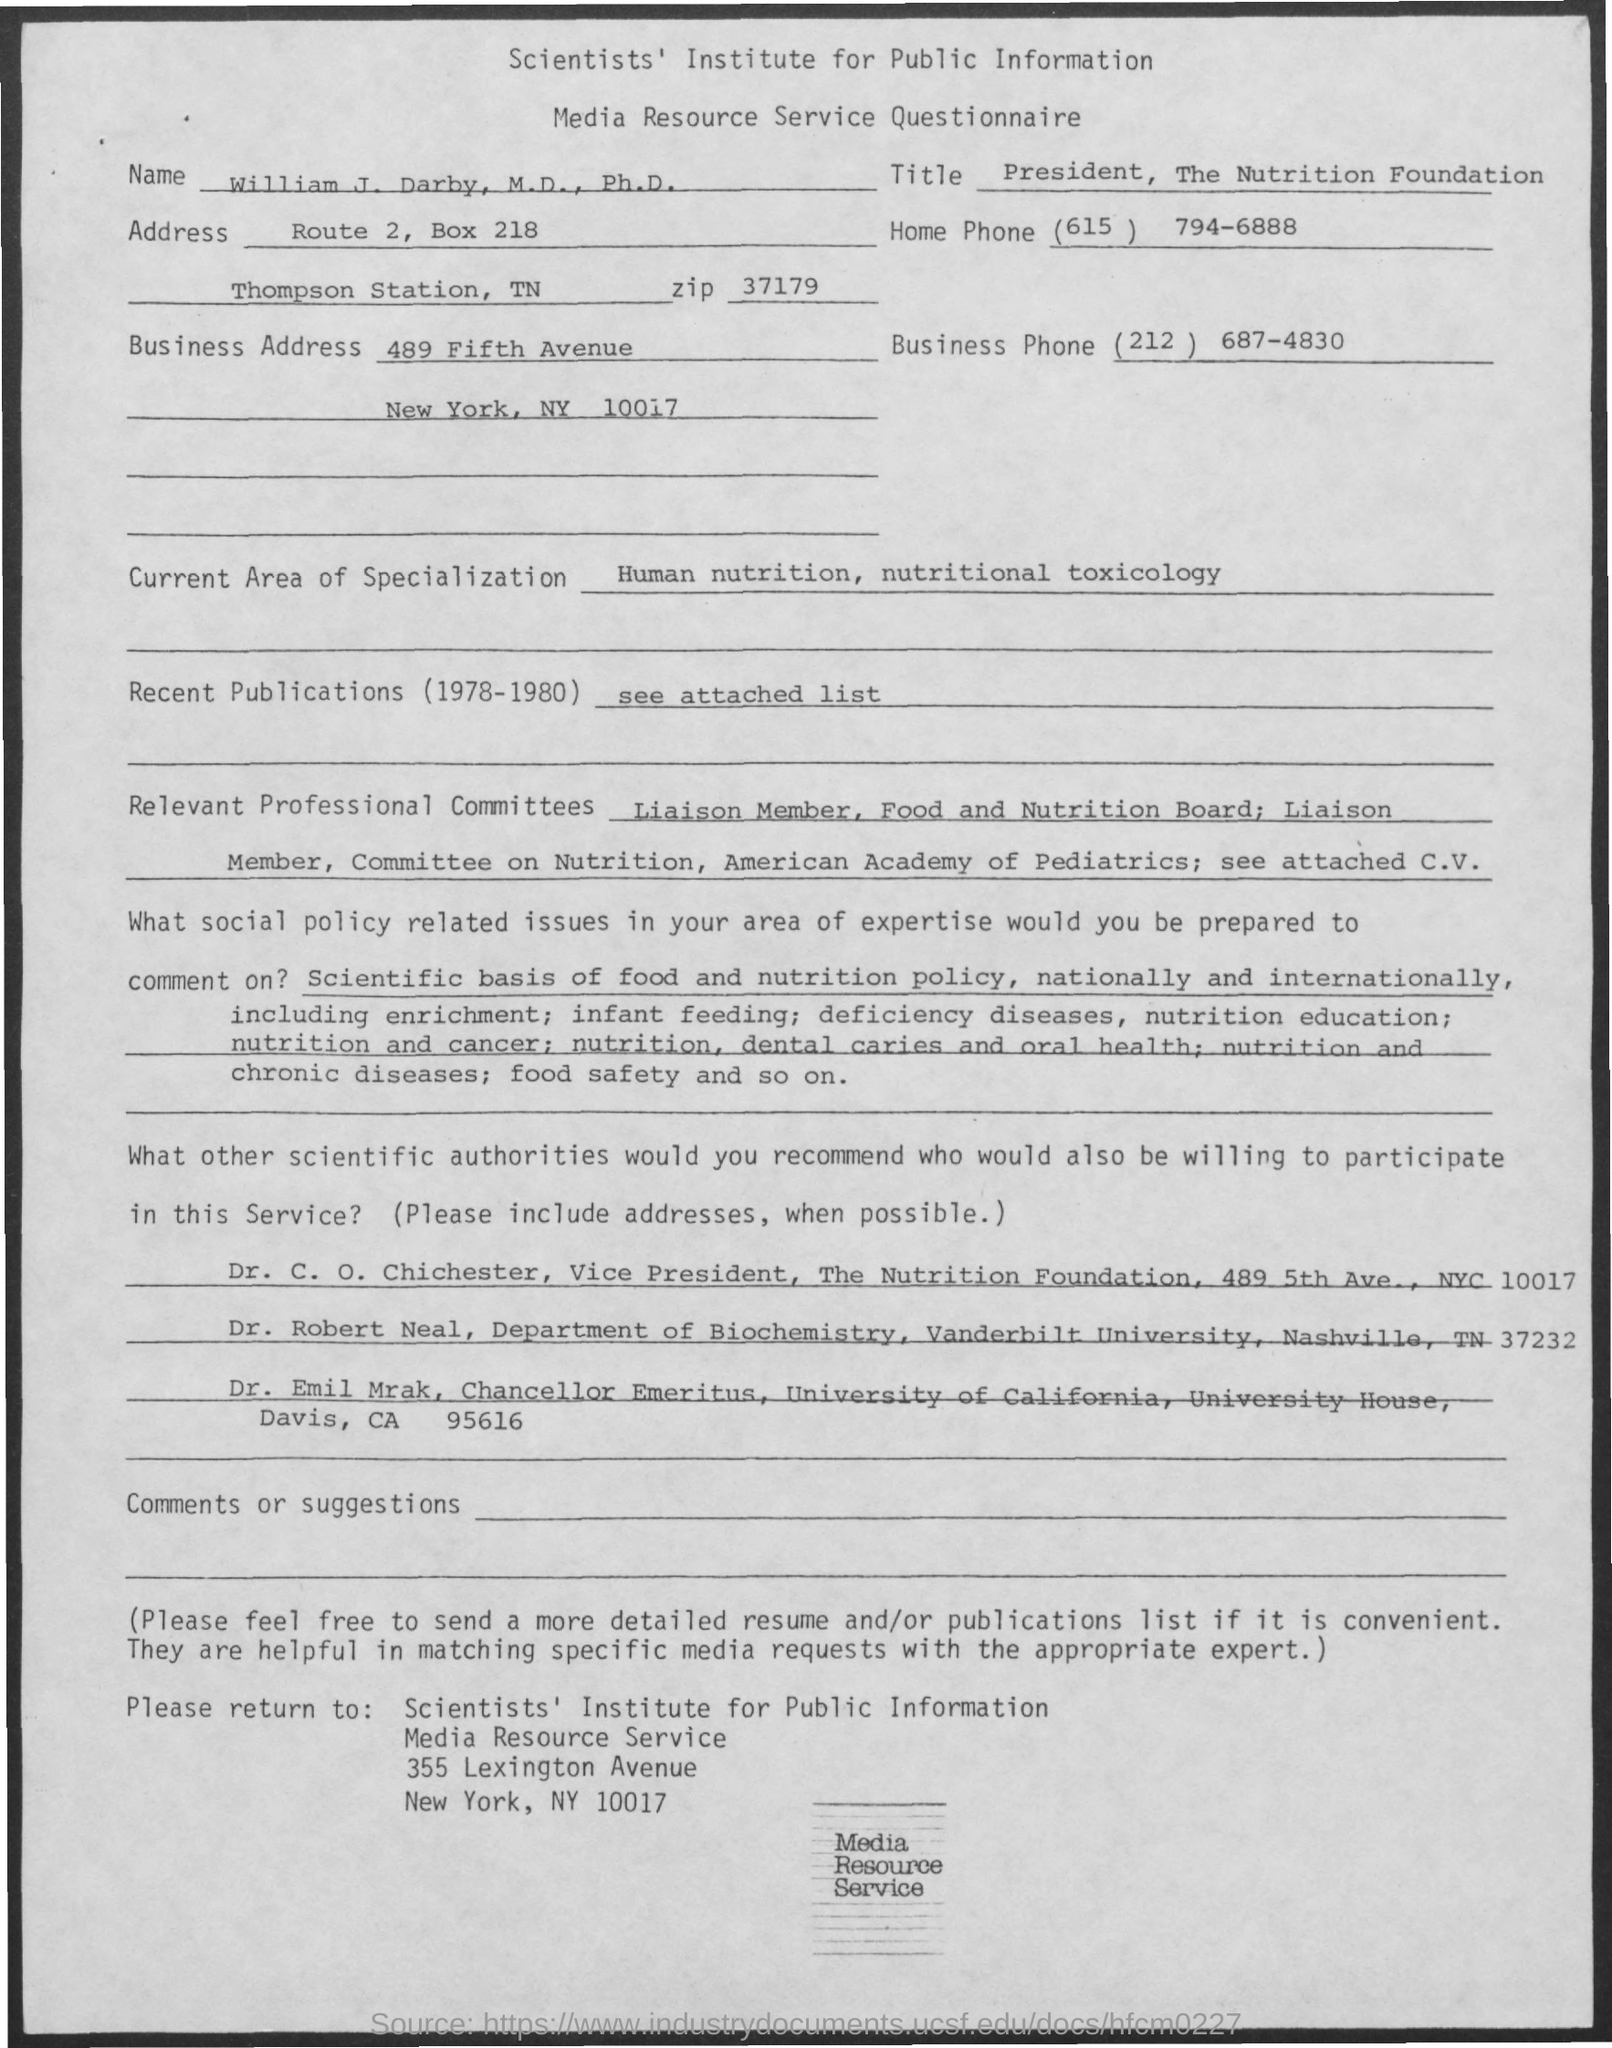Specify some key components in this picture. The home phone number is (615) 794-6888. The business phone number is (212) 687-4830. The document in question is titled "Media Resource Service Questionnaire. 